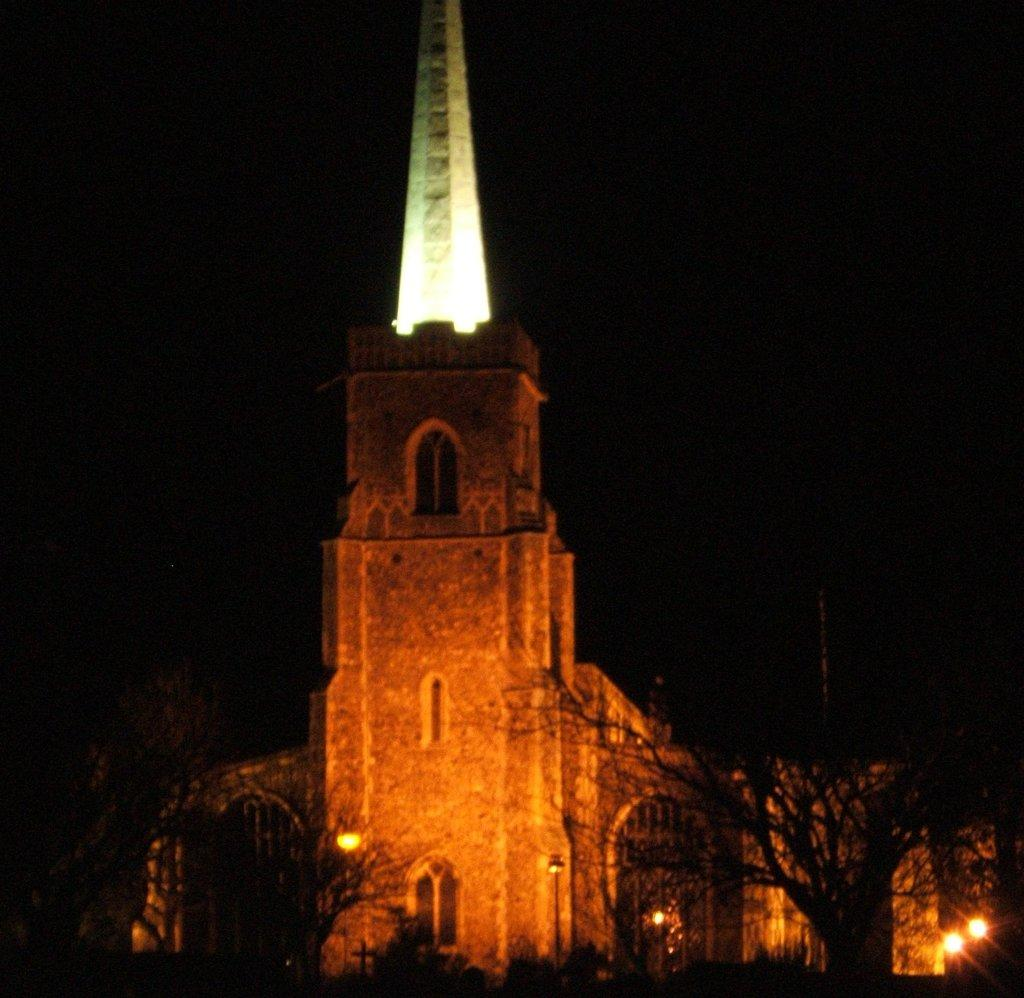What is the main structure in the image? There is a castle in the image. What type of natural elements can be seen in the image? There are trees in the image. What type of man-made structures are present in the image? There are light poles in the image. How would you describe the overall lighting in the image? The background of the image is dark. How many dogs are playing with balls in the image? There are no dogs or balls present in the image. 